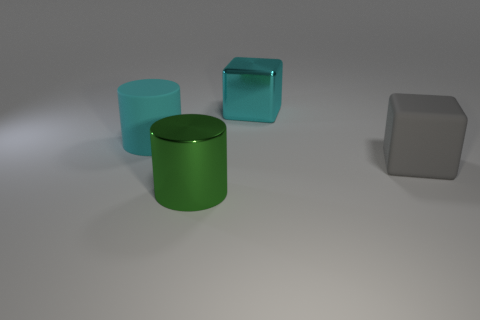Add 3 blue balls. How many objects exist? 7 Subtract 0 blue spheres. How many objects are left? 4 Subtract all large red shiny cubes. Subtract all big cubes. How many objects are left? 2 Add 3 matte objects. How many matte objects are left? 5 Add 1 green metal spheres. How many green metal spheres exist? 1 